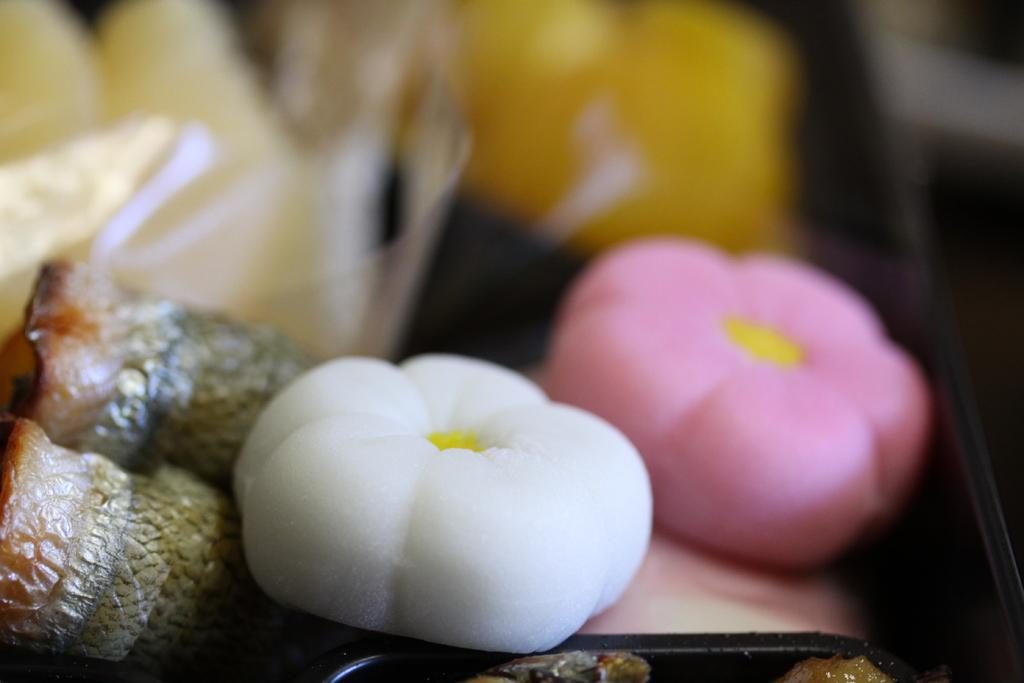What type of objects can be seen in the image? There are sweets in the image. Can you describe the background of the image? The background of the image is blurred. How many lizards are crawling on the sweets in the image? There are no lizards present in the image; it only features sweets. 